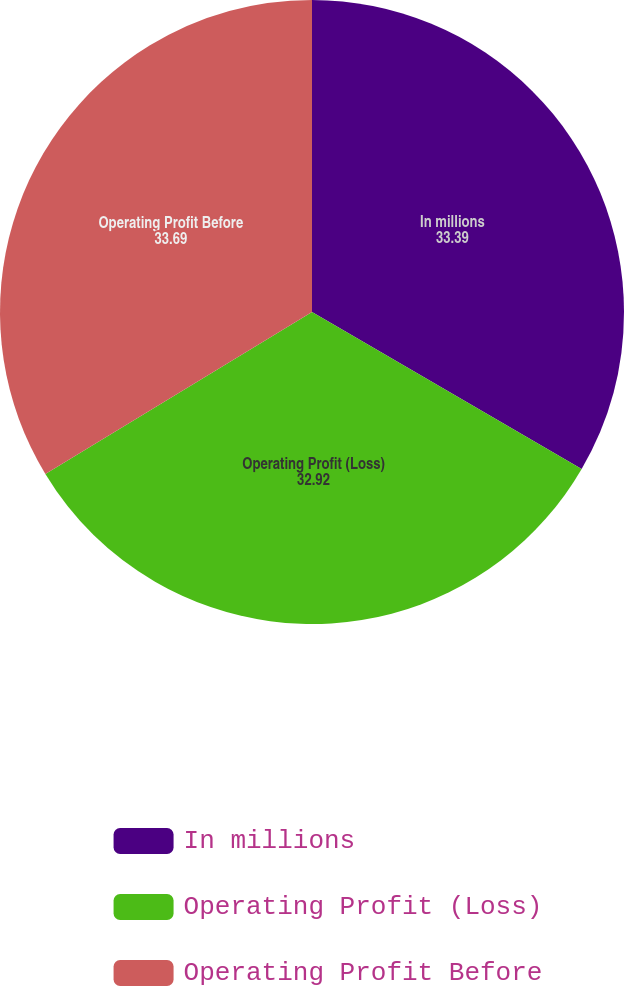Convert chart. <chart><loc_0><loc_0><loc_500><loc_500><pie_chart><fcel>In millions<fcel>Operating Profit (Loss)<fcel>Operating Profit Before<nl><fcel>33.39%<fcel>32.92%<fcel>33.69%<nl></chart> 